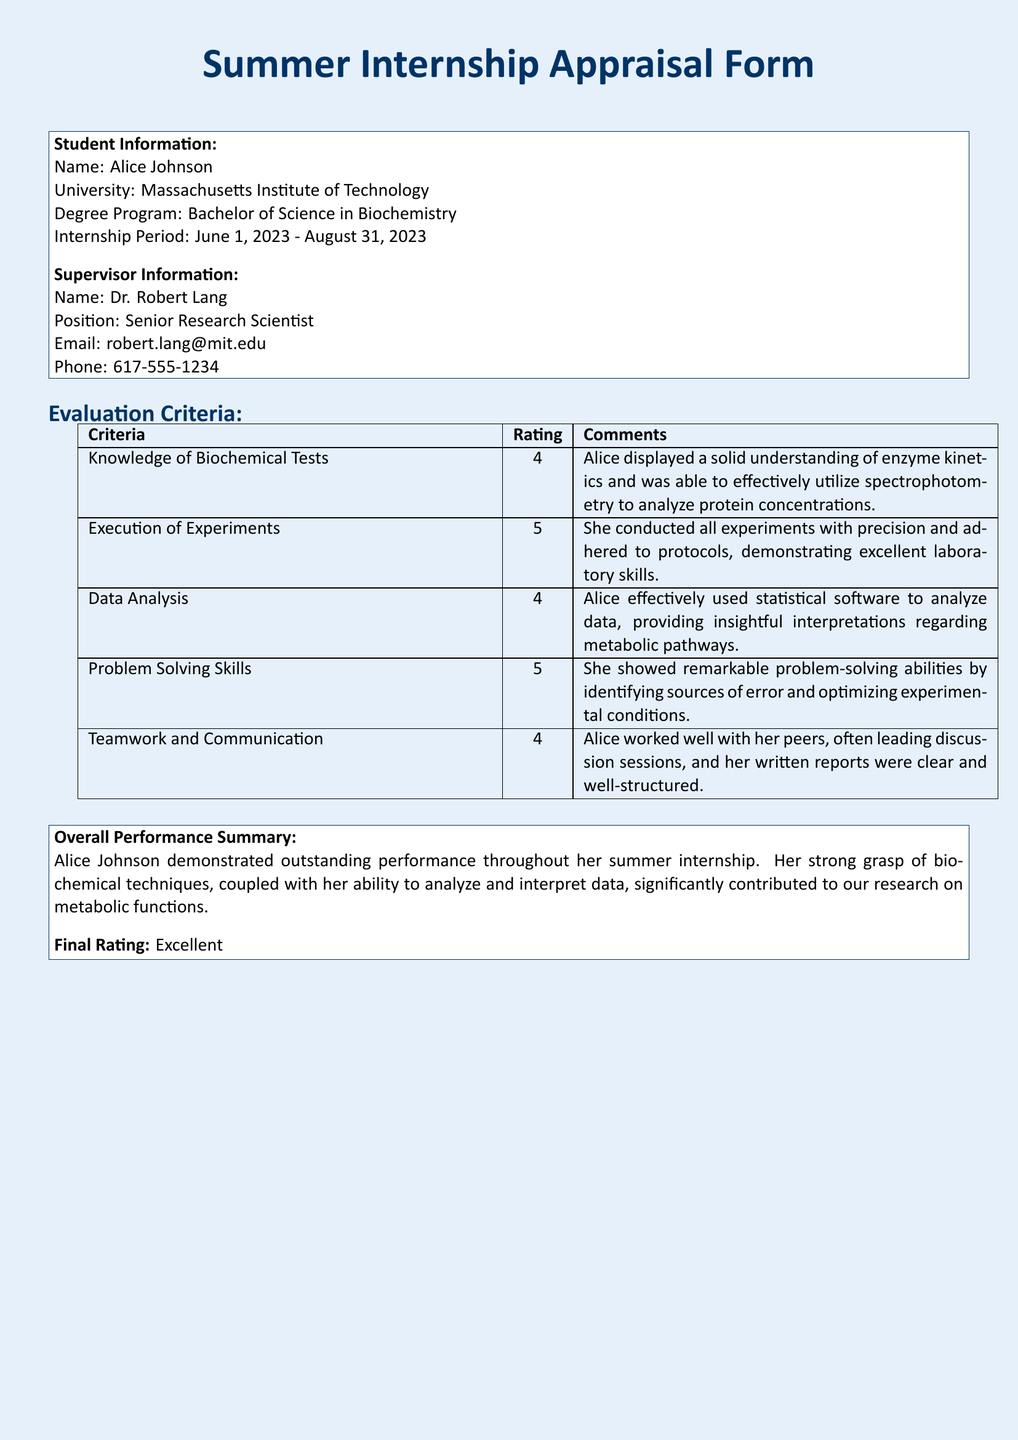What is the student's name? The student's name is written under Student Information as Alice Johnson.
Answer: Alice Johnson What university does the student attend? The university is mentioned in the Student Information section as Massachusetts Institute of Technology.
Answer: Massachusetts Institute of Technology What is the rating for Execution of Experiments? The rating for Execution of Experiments is noted in the Evaluation Criteria table as 5.
Answer: 5 Who is the supervisor? The supervisor's name is listed under Supervisor Information as Dr. Robert Lang.
Answer: Dr. Robert Lang What was the internship period? The internship period is specified in the Student Information section from June 1, 2023, to August 31, 2023.
Answer: June 1, 2023 - August 31, 2023 What does the Overall Performance Summary highlight about her understanding? The Overall Performance Summary states that Alice demonstrated a strong grasp of biochemical techniques.
Answer: Strong grasp of biochemical techniques What was Alice's Final Rating? The Final Rating is provided in the Overall Performance Summary as Excellent.
Answer: Excellent How many evaluation criteria are listed in the document? The Evaluation Criteria table includes five distinct criteria for assessment.
Answer: 5 Which skill did Alice demonstrate with a rating of 5 in the evaluation? Alice showed remarkable problem-solving abilities that received a rating of 5.
Answer: Problem-solving abilities 